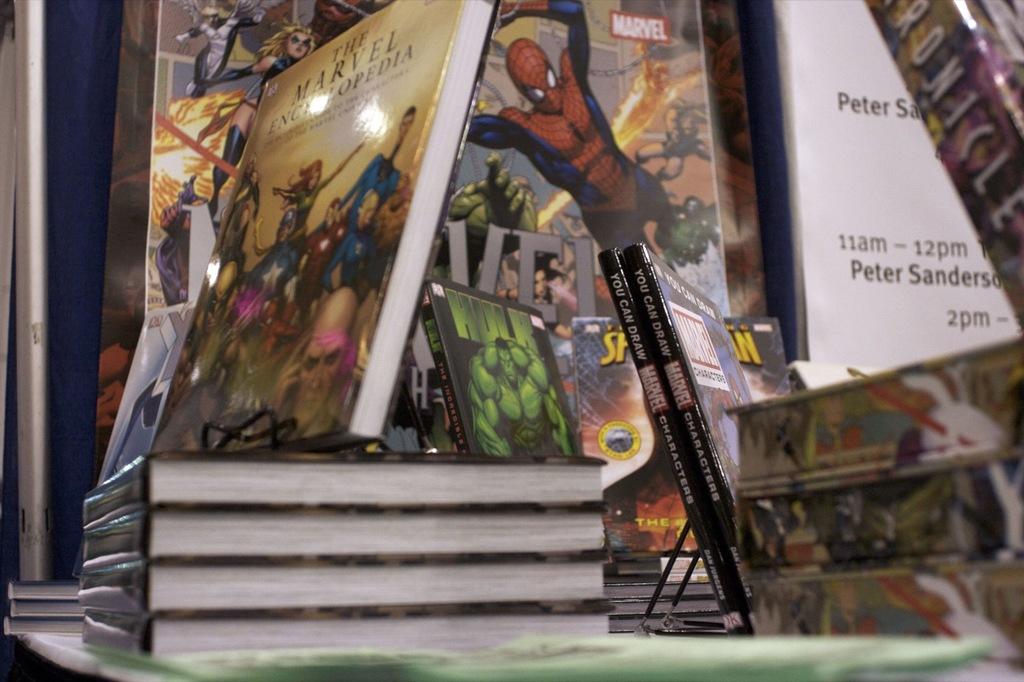What is the name of the green character in the middle?
Provide a succinct answer. Hulk. What male is there between 11am and 12pm?
Your answer should be compact. Peter sanderson. 